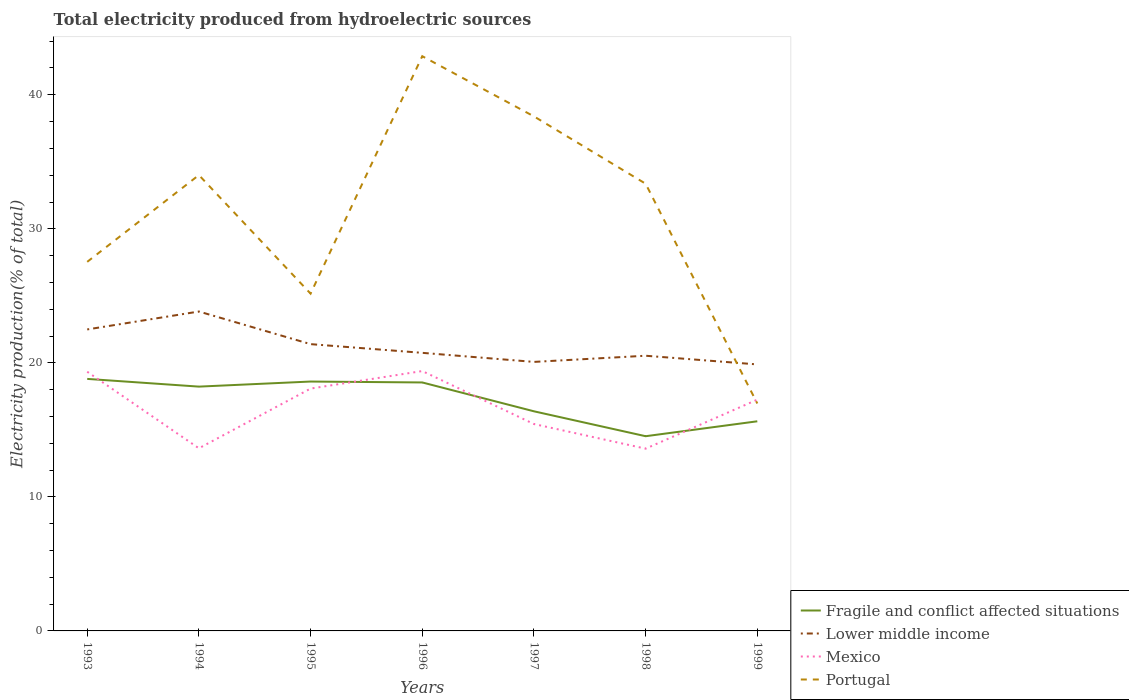Is the number of lines equal to the number of legend labels?
Ensure brevity in your answer.  Yes. Across all years, what is the maximum total electricity produced in Portugal?
Provide a short and direct response. 16.97. What is the total total electricity produced in Fragile and conflict affected situations in the graph?
Ensure brevity in your answer.  2.9. What is the difference between the highest and the second highest total electricity produced in Lower middle income?
Provide a short and direct response. 3.95. How many lines are there?
Provide a succinct answer. 4. How many years are there in the graph?
Provide a succinct answer. 7. Are the values on the major ticks of Y-axis written in scientific E-notation?
Keep it short and to the point. No. Does the graph contain any zero values?
Make the answer very short. No. Does the graph contain grids?
Your answer should be very brief. No. How many legend labels are there?
Your response must be concise. 4. What is the title of the graph?
Give a very brief answer. Total electricity produced from hydroelectric sources. What is the label or title of the X-axis?
Provide a succinct answer. Years. What is the Electricity production(% of total) in Fragile and conflict affected situations in 1993?
Keep it short and to the point. 18.8. What is the Electricity production(% of total) of Lower middle income in 1993?
Your response must be concise. 22.49. What is the Electricity production(% of total) in Mexico in 1993?
Your response must be concise. 19.34. What is the Electricity production(% of total) of Portugal in 1993?
Your answer should be very brief. 27.54. What is the Electricity production(% of total) of Fragile and conflict affected situations in 1994?
Keep it short and to the point. 18.23. What is the Electricity production(% of total) in Lower middle income in 1994?
Keep it short and to the point. 23.83. What is the Electricity production(% of total) in Mexico in 1994?
Provide a short and direct response. 13.63. What is the Electricity production(% of total) of Portugal in 1994?
Provide a short and direct response. 34.01. What is the Electricity production(% of total) in Fragile and conflict affected situations in 1995?
Provide a short and direct response. 18.61. What is the Electricity production(% of total) of Lower middle income in 1995?
Keep it short and to the point. 21.4. What is the Electricity production(% of total) of Mexico in 1995?
Your answer should be very brief. 18.08. What is the Electricity production(% of total) in Portugal in 1995?
Your answer should be very brief. 25.16. What is the Electricity production(% of total) of Fragile and conflict affected situations in 1996?
Make the answer very short. 18.54. What is the Electricity production(% of total) of Lower middle income in 1996?
Make the answer very short. 20.75. What is the Electricity production(% of total) of Mexico in 1996?
Your response must be concise. 19.39. What is the Electricity production(% of total) of Portugal in 1996?
Your answer should be compact. 42.88. What is the Electricity production(% of total) of Fragile and conflict affected situations in 1997?
Ensure brevity in your answer.  16.39. What is the Electricity production(% of total) of Lower middle income in 1997?
Provide a short and direct response. 20.07. What is the Electricity production(% of total) of Mexico in 1997?
Provide a short and direct response. 15.44. What is the Electricity production(% of total) of Portugal in 1997?
Keep it short and to the point. 38.39. What is the Electricity production(% of total) of Fragile and conflict affected situations in 1998?
Offer a terse response. 14.53. What is the Electricity production(% of total) of Lower middle income in 1998?
Provide a short and direct response. 20.53. What is the Electricity production(% of total) of Mexico in 1998?
Your answer should be very brief. 13.6. What is the Electricity production(% of total) of Portugal in 1998?
Provide a succinct answer. 33.36. What is the Electricity production(% of total) in Fragile and conflict affected situations in 1999?
Offer a terse response. 15.64. What is the Electricity production(% of total) in Lower middle income in 1999?
Provide a short and direct response. 19.88. What is the Electricity production(% of total) in Mexico in 1999?
Provide a succinct answer. 17.26. What is the Electricity production(% of total) in Portugal in 1999?
Offer a very short reply. 16.97. Across all years, what is the maximum Electricity production(% of total) in Fragile and conflict affected situations?
Your answer should be very brief. 18.8. Across all years, what is the maximum Electricity production(% of total) in Lower middle income?
Your answer should be compact. 23.83. Across all years, what is the maximum Electricity production(% of total) of Mexico?
Ensure brevity in your answer.  19.39. Across all years, what is the maximum Electricity production(% of total) of Portugal?
Your answer should be compact. 42.88. Across all years, what is the minimum Electricity production(% of total) of Fragile and conflict affected situations?
Your response must be concise. 14.53. Across all years, what is the minimum Electricity production(% of total) of Lower middle income?
Ensure brevity in your answer.  19.88. Across all years, what is the minimum Electricity production(% of total) in Mexico?
Your response must be concise. 13.6. Across all years, what is the minimum Electricity production(% of total) of Portugal?
Your answer should be very brief. 16.97. What is the total Electricity production(% of total) in Fragile and conflict affected situations in the graph?
Provide a succinct answer. 120.72. What is the total Electricity production(% of total) in Lower middle income in the graph?
Your answer should be very brief. 148.95. What is the total Electricity production(% of total) in Mexico in the graph?
Offer a terse response. 116.72. What is the total Electricity production(% of total) in Portugal in the graph?
Keep it short and to the point. 218.31. What is the difference between the Electricity production(% of total) in Fragile and conflict affected situations in 1993 and that in 1994?
Your answer should be very brief. 0.58. What is the difference between the Electricity production(% of total) of Lower middle income in 1993 and that in 1994?
Provide a succinct answer. -1.34. What is the difference between the Electricity production(% of total) in Mexico in 1993 and that in 1994?
Provide a succinct answer. 5.71. What is the difference between the Electricity production(% of total) of Portugal in 1993 and that in 1994?
Your response must be concise. -6.47. What is the difference between the Electricity production(% of total) of Fragile and conflict affected situations in 1993 and that in 1995?
Ensure brevity in your answer.  0.2. What is the difference between the Electricity production(% of total) of Lower middle income in 1993 and that in 1995?
Keep it short and to the point. 1.1. What is the difference between the Electricity production(% of total) of Mexico in 1993 and that in 1995?
Your answer should be very brief. 1.26. What is the difference between the Electricity production(% of total) in Portugal in 1993 and that in 1995?
Provide a succinct answer. 2.37. What is the difference between the Electricity production(% of total) in Fragile and conflict affected situations in 1993 and that in 1996?
Keep it short and to the point. 0.27. What is the difference between the Electricity production(% of total) in Lower middle income in 1993 and that in 1996?
Your response must be concise. 1.75. What is the difference between the Electricity production(% of total) of Mexico in 1993 and that in 1996?
Give a very brief answer. -0.05. What is the difference between the Electricity production(% of total) in Portugal in 1993 and that in 1996?
Make the answer very short. -15.34. What is the difference between the Electricity production(% of total) of Fragile and conflict affected situations in 1993 and that in 1997?
Your answer should be very brief. 2.42. What is the difference between the Electricity production(% of total) in Lower middle income in 1993 and that in 1997?
Make the answer very short. 2.42. What is the difference between the Electricity production(% of total) of Mexico in 1993 and that in 1997?
Keep it short and to the point. 3.9. What is the difference between the Electricity production(% of total) in Portugal in 1993 and that in 1997?
Offer a terse response. -10.85. What is the difference between the Electricity production(% of total) in Fragile and conflict affected situations in 1993 and that in 1998?
Provide a short and direct response. 4.28. What is the difference between the Electricity production(% of total) in Lower middle income in 1993 and that in 1998?
Offer a very short reply. 1.96. What is the difference between the Electricity production(% of total) of Mexico in 1993 and that in 1998?
Give a very brief answer. 5.74. What is the difference between the Electricity production(% of total) of Portugal in 1993 and that in 1998?
Keep it short and to the point. -5.83. What is the difference between the Electricity production(% of total) in Fragile and conflict affected situations in 1993 and that in 1999?
Offer a very short reply. 3.16. What is the difference between the Electricity production(% of total) in Lower middle income in 1993 and that in 1999?
Offer a very short reply. 2.61. What is the difference between the Electricity production(% of total) in Mexico in 1993 and that in 1999?
Make the answer very short. 2.08. What is the difference between the Electricity production(% of total) in Portugal in 1993 and that in 1999?
Keep it short and to the point. 10.57. What is the difference between the Electricity production(% of total) in Fragile and conflict affected situations in 1994 and that in 1995?
Keep it short and to the point. -0.38. What is the difference between the Electricity production(% of total) of Lower middle income in 1994 and that in 1995?
Provide a short and direct response. 2.43. What is the difference between the Electricity production(% of total) in Mexico in 1994 and that in 1995?
Make the answer very short. -4.46. What is the difference between the Electricity production(% of total) in Portugal in 1994 and that in 1995?
Provide a short and direct response. 8.85. What is the difference between the Electricity production(% of total) of Fragile and conflict affected situations in 1994 and that in 1996?
Make the answer very short. -0.31. What is the difference between the Electricity production(% of total) in Lower middle income in 1994 and that in 1996?
Offer a very short reply. 3.08. What is the difference between the Electricity production(% of total) of Mexico in 1994 and that in 1996?
Your response must be concise. -5.76. What is the difference between the Electricity production(% of total) in Portugal in 1994 and that in 1996?
Provide a succinct answer. -8.87. What is the difference between the Electricity production(% of total) of Fragile and conflict affected situations in 1994 and that in 1997?
Your answer should be compact. 1.84. What is the difference between the Electricity production(% of total) of Lower middle income in 1994 and that in 1997?
Your answer should be very brief. 3.76. What is the difference between the Electricity production(% of total) in Mexico in 1994 and that in 1997?
Your answer should be very brief. -1.81. What is the difference between the Electricity production(% of total) of Portugal in 1994 and that in 1997?
Make the answer very short. -4.38. What is the difference between the Electricity production(% of total) of Fragile and conflict affected situations in 1994 and that in 1998?
Your answer should be very brief. 3.7. What is the difference between the Electricity production(% of total) in Lower middle income in 1994 and that in 1998?
Ensure brevity in your answer.  3.3. What is the difference between the Electricity production(% of total) in Mexico in 1994 and that in 1998?
Provide a short and direct response. 0.03. What is the difference between the Electricity production(% of total) in Portugal in 1994 and that in 1998?
Provide a succinct answer. 0.65. What is the difference between the Electricity production(% of total) in Fragile and conflict affected situations in 1994 and that in 1999?
Your response must be concise. 2.59. What is the difference between the Electricity production(% of total) in Lower middle income in 1994 and that in 1999?
Give a very brief answer. 3.95. What is the difference between the Electricity production(% of total) in Mexico in 1994 and that in 1999?
Provide a succinct answer. -3.63. What is the difference between the Electricity production(% of total) of Portugal in 1994 and that in 1999?
Provide a short and direct response. 17.04. What is the difference between the Electricity production(% of total) in Fragile and conflict affected situations in 1995 and that in 1996?
Give a very brief answer. 0.07. What is the difference between the Electricity production(% of total) in Lower middle income in 1995 and that in 1996?
Your answer should be compact. 0.65. What is the difference between the Electricity production(% of total) in Mexico in 1995 and that in 1996?
Your answer should be compact. -1.31. What is the difference between the Electricity production(% of total) of Portugal in 1995 and that in 1996?
Your response must be concise. -17.71. What is the difference between the Electricity production(% of total) in Fragile and conflict affected situations in 1995 and that in 1997?
Give a very brief answer. 2.22. What is the difference between the Electricity production(% of total) in Lower middle income in 1995 and that in 1997?
Provide a short and direct response. 1.33. What is the difference between the Electricity production(% of total) of Mexico in 1995 and that in 1997?
Your answer should be compact. 2.65. What is the difference between the Electricity production(% of total) in Portugal in 1995 and that in 1997?
Your response must be concise. -13.22. What is the difference between the Electricity production(% of total) of Fragile and conflict affected situations in 1995 and that in 1998?
Your answer should be compact. 4.08. What is the difference between the Electricity production(% of total) in Lower middle income in 1995 and that in 1998?
Provide a succinct answer. 0.87. What is the difference between the Electricity production(% of total) in Mexico in 1995 and that in 1998?
Ensure brevity in your answer.  4.48. What is the difference between the Electricity production(% of total) of Portugal in 1995 and that in 1998?
Your answer should be very brief. -8.2. What is the difference between the Electricity production(% of total) of Fragile and conflict affected situations in 1995 and that in 1999?
Your response must be concise. 2.97. What is the difference between the Electricity production(% of total) of Lower middle income in 1995 and that in 1999?
Your answer should be very brief. 1.51. What is the difference between the Electricity production(% of total) of Mexico in 1995 and that in 1999?
Your answer should be compact. 0.83. What is the difference between the Electricity production(% of total) in Portugal in 1995 and that in 1999?
Keep it short and to the point. 8.2. What is the difference between the Electricity production(% of total) in Fragile and conflict affected situations in 1996 and that in 1997?
Give a very brief answer. 2.15. What is the difference between the Electricity production(% of total) in Lower middle income in 1996 and that in 1997?
Your answer should be compact. 0.68. What is the difference between the Electricity production(% of total) of Mexico in 1996 and that in 1997?
Keep it short and to the point. 3.95. What is the difference between the Electricity production(% of total) in Portugal in 1996 and that in 1997?
Provide a short and direct response. 4.49. What is the difference between the Electricity production(% of total) in Fragile and conflict affected situations in 1996 and that in 1998?
Offer a very short reply. 4.01. What is the difference between the Electricity production(% of total) of Lower middle income in 1996 and that in 1998?
Provide a succinct answer. 0.22. What is the difference between the Electricity production(% of total) of Mexico in 1996 and that in 1998?
Provide a short and direct response. 5.79. What is the difference between the Electricity production(% of total) of Portugal in 1996 and that in 1998?
Offer a terse response. 9.51. What is the difference between the Electricity production(% of total) in Fragile and conflict affected situations in 1996 and that in 1999?
Offer a very short reply. 2.9. What is the difference between the Electricity production(% of total) in Lower middle income in 1996 and that in 1999?
Make the answer very short. 0.86. What is the difference between the Electricity production(% of total) of Mexico in 1996 and that in 1999?
Your answer should be very brief. 2.13. What is the difference between the Electricity production(% of total) in Portugal in 1996 and that in 1999?
Provide a succinct answer. 25.91. What is the difference between the Electricity production(% of total) of Fragile and conflict affected situations in 1997 and that in 1998?
Provide a succinct answer. 1.86. What is the difference between the Electricity production(% of total) in Lower middle income in 1997 and that in 1998?
Keep it short and to the point. -0.46. What is the difference between the Electricity production(% of total) of Mexico in 1997 and that in 1998?
Ensure brevity in your answer.  1.84. What is the difference between the Electricity production(% of total) of Portugal in 1997 and that in 1998?
Make the answer very short. 5.02. What is the difference between the Electricity production(% of total) of Fragile and conflict affected situations in 1997 and that in 1999?
Your answer should be very brief. 0.75. What is the difference between the Electricity production(% of total) of Lower middle income in 1997 and that in 1999?
Keep it short and to the point. 0.19. What is the difference between the Electricity production(% of total) in Mexico in 1997 and that in 1999?
Your answer should be compact. -1.82. What is the difference between the Electricity production(% of total) of Portugal in 1997 and that in 1999?
Provide a succinct answer. 21.42. What is the difference between the Electricity production(% of total) in Fragile and conflict affected situations in 1998 and that in 1999?
Your response must be concise. -1.11. What is the difference between the Electricity production(% of total) in Lower middle income in 1998 and that in 1999?
Offer a terse response. 0.65. What is the difference between the Electricity production(% of total) of Mexico in 1998 and that in 1999?
Give a very brief answer. -3.66. What is the difference between the Electricity production(% of total) of Portugal in 1998 and that in 1999?
Keep it short and to the point. 16.4. What is the difference between the Electricity production(% of total) of Fragile and conflict affected situations in 1993 and the Electricity production(% of total) of Lower middle income in 1994?
Give a very brief answer. -5.03. What is the difference between the Electricity production(% of total) in Fragile and conflict affected situations in 1993 and the Electricity production(% of total) in Mexico in 1994?
Provide a succinct answer. 5.18. What is the difference between the Electricity production(% of total) in Fragile and conflict affected situations in 1993 and the Electricity production(% of total) in Portugal in 1994?
Offer a terse response. -15.21. What is the difference between the Electricity production(% of total) of Lower middle income in 1993 and the Electricity production(% of total) of Mexico in 1994?
Offer a very short reply. 8.87. What is the difference between the Electricity production(% of total) in Lower middle income in 1993 and the Electricity production(% of total) in Portugal in 1994?
Give a very brief answer. -11.52. What is the difference between the Electricity production(% of total) in Mexico in 1993 and the Electricity production(% of total) in Portugal in 1994?
Offer a very short reply. -14.67. What is the difference between the Electricity production(% of total) of Fragile and conflict affected situations in 1993 and the Electricity production(% of total) of Lower middle income in 1995?
Make the answer very short. -2.59. What is the difference between the Electricity production(% of total) of Fragile and conflict affected situations in 1993 and the Electricity production(% of total) of Mexico in 1995?
Your answer should be compact. 0.72. What is the difference between the Electricity production(% of total) of Fragile and conflict affected situations in 1993 and the Electricity production(% of total) of Portugal in 1995?
Offer a terse response. -6.36. What is the difference between the Electricity production(% of total) in Lower middle income in 1993 and the Electricity production(% of total) in Mexico in 1995?
Your answer should be very brief. 4.41. What is the difference between the Electricity production(% of total) of Lower middle income in 1993 and the Electricity production(% of total) of Portugal in 1995?
Keep it short and to the point. -2.67. What is the difference between the Electricity production(% of total) of Mexico in 1993 and the Electricity production(% of total) of Portugal in 1995?
Keep it short and to the point. -5.83. What is the difference between the Electricity production(% of total) of Fragile and conflict affected situations in 1993 and the Electricity production(% of total) of Lower middle income in 1996?
Give a very brief answer. -1.94. What is the difference between the Electricity production(% of total) of Fragile and conflict affected situations in 1993 and the Electricity production(% of total) of Mexico in 1996?
Provide a short and direct response. -0.59. What is the difference between the Electricity production(% of total) of Fragile and conflict affected situations in 1993 and the Electricity production(% of total) of Portugal in 1996?
Your answer should be very brief. -24.08. What is the difference between the Electricity production(% of total) of Lower middle income in 1993 and the Electricity production(% of total) of Mexico in 1996?
Provide a short and direct response. 3.1. What is the difference between the Electricity production(% of total) of Lower middle income in 1993 and the Electricity production(% of total) of Portugal in 1996?
Keep it short and to the point. -20.39. What is the difference between the Electricity production(% of total) in Mexico in 1993 and the Electricity production(% of total) in Portugal in 1996?
Provide a succinct answer. -23.54. What is the difference between the Electricity production(% of total) of Fragile and conflict affected situations in 1993 and the Electricity production(% of total) of Lower middle income in 1997?
Your response must be concise. -1.27. What is the difference between the Electricity production(% of total) in Fragile and conflict affected situations in 1993 and the Electricity production(% of total) in Mexico in 1997?
Offer a very short reply. 3.37. What is the difference between the Electricity production(% of total) of Fragile and conflict affected situations in 1993 and the Electricity production(% of total) of Portugal in 1997?
Offer a very short reply. -19.59. What is the difference between the Electricity production(% of total) in Lower middle income in 1993 and the Electricity production(% of total) in Mexico in 1997?
Keep it short and to the point. 7.06. What is the difference between the Electricity production(% of total) in Lower middle income in 1993 and the Electricity production(% of total) in Portugal in 1997?
Provide a short and direct response. -15.9. What is the difference between the Electricity production(% of total) of Mexico in 1993 and the Electricity production(% of total) of Portugal in 1997?
Provide a short and direct response. -19.05. What is the difference between the Electricity production(% of total) of Fragile and conflict affected situations in 1993 and the Electricity production(% of total) of Lower middle income in 1998?
Your answer should be very brief. -1.73. What is the difference between the Electricity production(% of total) of Fragile and conflict affected situations in 1993 and the Electricity production(% of total) of Mexico in 1998?
Ensure brevity in your answer.  5.2. What is the difference between the Electricity production(% of total) of Fragile and conflict affected situations in 1993 and the Electricity production(% of total) of Portugal in 1998?
Keep it short and to the point. -14.56. What is the difference between the Electricity production(% of total) in Lower middle income in 1993 and the Electricity production(% of total) in Mexico in 1998?
Offer a terse response. 8.89. What is the difference between the Electricity production(% of total) in Lower middle income in 1993 and the Electricity production(% of total) in Portugal in 1998?
Your response must be concise. -10.87. What is the difference between the Electricity production(% of total) of Mexico in 1993 and the Electricity production(% of total) of Portugal in 1998?
Keep it short and to the point. -14.03. What is the difference between the Electricity production(% of total) of Fragile and conflict affected situations in 1993 and the Electricity production(% of total) of Lower middle income in 1999?
Keep it short and to the point. -1.08. What is the difference between the Electricity production(% of total) of Fragile and conflict affected situations in 1993 and the Electricity production(% of total) of Mexico in 1999?
Make the answer very short. 1.55. What is the difference between the Electricity production(% of total) in Fragile and conflict affected situations in 1993 and the Electricity production(% of total) in Portugal in 1999?
Your response must be concise. 1.84. What is the difference between the Electricity production(% of total) in Lower middle income in 1993 and the Electricity production(% of total) in Mexico in 1999?
Your answer should be very brief. 5.24. What is the difference between the Electricity production(% of total) of Lower middle income in 1993 and the Electricity production(% of total) of Portugal in 1999?
Give a very brief answer. 5.53. What is the difference between the Electricity production(% of total) of Mexico in 1993 and the Electricity production(% of total) of Portugal in 1999?
Make the answer very short. 2.37. What is the difference between the Electricity production(% of total) in Fragile and conflict affected situations in 1994 and the Electricity production(% of total) in Lower middle income in 1995?
Offer a very short reply. -3.17. What is the difference between the Electricity production(% of total) of Fragile and conflict affected situations in 1994 and the Electricity production(% of total) of Mexico in 1995?
Offer a very short reply. 0.15. What is the difference between the Electricity production(% of total) of Fragile and conflict affected situations in 1994 and the Electricity production(% of total) of Portugal in 1995?
Ensure brevity in your answer.  -6.94. What is the difference between the Electricity production(% of total) in Lower middle income in 1994 and the Electricity production(% of total) in Mexico in 1995?
Keep it short and to the point. 5.75. What is the difference between the Electricity production(% of total) of Lower middle income in 1994 and the Electricity production(% of total) of Portugal in 1995?
Provide a short and direct response. -1.33. What is the difference between the Electricity production(% of total) in Mexico in 1994 and the Electricity production(% of total) in Portugal in 1995?
Your response must be concise. -11.54. What is the difference between the Electricity production(% of total) of Fragile and conflict affected situations in 1994 and the Electricity production(% of total) of Lower middle income in 1996?
Your answer should be compact. -2.52. What is the difference between the Electricity production(% of total) in Fragile and conflict affected situations in 1994 and the Electricity production(% of total) in Mexico in 1996?
Ensure brevity in your answer.  -1.16. What is the difference between the Electricity production(% of total) in Fragile and conflict affected situations in 1994 and the Electricity production(% of total) in Portugal in 1996?
Ensure brevity in your answer.  -24.65. What is the difference between the Electricity production(% of total) in Lower middle income in 1994 and the Electricity production(% of total) in Mexico in 1996?
Give a very brief answer. 4.44. What is the difference between the Electricity production(% of total) in Lower middle income in 1994 and the Electricity production(% of total) in Portugal in 1996?
Your response must be concise. -19.05. What is the difference between the Electricity production(% of total) of Mexico in 1994 and the Electricity production(% of total) of Portugal in 1996?
Provide a short and direct response. -29.25. What is the difference between the Electricity production(% of total) of Fragile and conflict affected situations in 1994 and the Electricity production(% of total) of Lower middle income in 1997?
Make the answer very short. -1.84. What is the difference between the Electricity production(% of total) in Fragile and conflict affected situations in 1994 and the Electricity production(% of total) in Mexico in 1997?
Ensure brevity in your answer.  2.79. What is the difference between the Electricity production(% of total) in Fragile and conflict affected situations in 1994 and the Electricity production(% of total) in Portugal in 1997?
Your answer should be compact. -20.16. What is the difference between the Electricity production(% of total) in Lower middle income in 1994 and the Electricity production(% of total) in Mexico in 1997?
Provide a succinct answer. 8.39. What is the difference between the Electricity production(% of total) in Lower middle income in 1994 and the Electricity production(% of total) in Portugal in 1997?
Offer a very short reply. -14.56. What is the difference between the Electricity production(% of total) of Mexico in 1994 and the Electricity production(% of total) of Portugal in 1997?
Your answer should be compact. -24.76. What is the difference between the Electricity production(% of total) in Fragile and conflict affected situations in 1994 and the Electricity production(% of total) in Lower middle income in 1998?
Ensure brevity in your answer.  -2.3. What is the difference between the Electricity production(% of total) in Fragile and conflict affected situations in 1994 and the Electricity production(% of total) in Mexico in 1998?
Your answer should be very brief. 4.63. What is the difference between the Electricity production(% of total) of Fragile and conflict affected situations in 1994 and the Electricity production(% of total) of Portugal in 1998?
Give a very brief answer. -15.14. What is the difference between the Electricity production(% of total) in Lower middle income in 1994 and the Electricity production(% of total) in Mexico in 1998?
Provide a succinct answer. 10.23. What is the difference between the Electricity production(% of total) in Lower middle income in 1994 and the Electricity production(% of total) in Portugal in 1998?
Offer a very short reply. -9.53. What is the difference between the Electricity production(% of total) of Mexico in 1994 and the Electricity production(% of total) of Portugal in 1998?
Your answer should be very brief. -19.74. What is the difference between the Electricity production(% of total) of Fragile and conflict affected situations in 1994 and the Electricity production(% of total) of Lower middle income in 1999?
Keep it short and to the point. -1.66. What is the difference between the Electricity production(% of total) in Fragile and conflict affected situations in 1994 and the Electricity production(% of total) in Mexico in 1999?
Make the answer very short. 0.97. What is the difference between the Electricity production(% of total) of Fragile and conflict affected situations in 1994 and the Electricity production(% of total) of Portugal in 1999?
Your answer should be compact. 1.26. What is the difference between the Electricity production(% of total) of Lower middle income in 1994 and the Electricity production(% of total) of Mexico in 1999?
Your response must be concise. 6.57. What is the difference between the Electricity production(% of total) in Lower middle income in 1994 and the Electricity production(% of total) in Portugal in 1999?
Your answer should be compact. 6.86. What is the difference between the Electricity production(% of total) of Mexico in 1994 and the Electricity production(% of total) of Portugal in 1999?
Your answer should be compact. -3.34. What is the difference between the Electricity production(% of total) of Fragile and conflict affected situations in 1995 and the Electricity production(% of total) of Lower middle income in 1996?
Provide a short and direct response. -2.14. What is the difference between the Electricity production(% of total) of Fragile and conflict affected situations in 1995 and the Electricity production(% of total) of Mexico in 1996?
Your answer should be compact. -0.78. What is the difference between the Electricity production(% of total) in Fragile and conflict affected situations in 1995 and the Electricity production(% of total) in Portugal in 1996?
Provide a succinct answer. -24.27. What is the difference between the Electricity production(% of total) of Lower middle income in 1995 and the Electricity production(% of total) of Mexico in 1996?
Offer a terse response. 2.01. What is the difference between the Electricity production(% of total) of Lower middle income in 1995 and the Electricity production(% of total) of Portugal in 1996?
Make the answer very short. -21.48. What is the difference between the Electricity production(% of total) of Mexico in 1995 and the Electricity production(% of total) of Portugal in 1996?
Provide a short and direct response. -24.8. What is the difference between the Electricity production(% of total) of Fragile and conflict affected situations in 1995 and the Electricity production(% of total) of Lower middle income in 1997?
Provide a succinct answer. -1.47. What is the difference between the Electricity production(% of total) of Fragile and conflict affected situations in 1995 and the Electricity production(% of total) of Mexico in 1997?
Ensure brevity in your answer.  3.17. What is the difference between the Electricity production(% of total) of Fragile and conflict affected situations in 1995 and the Electricity production(% of total) of Portugal in 1997?
Offer a very short reply. -19.78. What is the difference between the Electricity production(% of total) in Lower middle income in 1995 and the Electricity production(% of total) in Mexico in 1997?
Give a very brief answer. 5.96. What is the difference between the Electricity production(% of total) in Lower middle income in 1995 and the Electricity production(% of total) in Portugal in 1997?
Your response must be concise. -16.99. What is the difference between the Electricity production(% of total) in Mexico in 1995 and the Electricity production(% of total) in Portugal in 1997?
Offer a terse response. -20.31. What is the difference between the Electricity production(% of total) of Fragile and conflict affected situations in 1995 and the Electricity production(% of total) of Lower middle income in 1998?
Make the answer very short. -1.93. What is the difference between the Electricity production(% of total) of Fragile and conflict affected situations in 1995 and the Electricity production(% of total) of Mexico in 1998?
Offer a terse response. 5.01. What is the difference between the Electricity production(% of total) of Fragile and conflict affected situations in 1995 and the Electricity production(% of total) of Portugal in 1998?
Give a very brief answer. -14.76. What is the difference between the Electricity production(% of total) in Lower middle income in 1995 and the Electricity production(% of total) in Mexico in 1998?
Your answer should be compact. 7.8. What is the difference between the Electricity production(% of total) in Lower middle income in 1995 and the Electricity production(% of total) in Portugal in 1998?
Your answer should be compact. -11.97. What is the difference between the Electricity production(% of total) of Mexico in 1995 and the Electricity production(% of total) of Portugal in 1998?
Offer a terse response. -15.28. What is the difference between the Electricity production(% of total) in Fragile and conflict affected situations in 1995 and the Electricity production(% of total) in Lower middle income in 1999?
Your response must be concise. -1.28. What is the difference between the Electricity production(% of total) of Fragile and conflict affected situations in 1995 and the Electricity production(% of total) of Mexico in 1999?
Give a very brief answer. 1.35. What is the difference between the Electricity production(% of total) of Fragile and conflict affected situations in 1995 and the Electricity production(% of total) of Portugal in 1999?
Ensure brevity in your answer.  1.64. What is the difference between the Electricity production(% of total) in Lower middle income in 1995 and the Electricity production(% of total) in Mexico in 1999?
Ensure brevity in your answer.  4.14. What is the difference between the Electricity production(% of total) of Lower middle income in 1995 and the Electricity production(% of total) of Portugal in 1999?
Provide a succinct answer. 4.43. What is the difference between the Electricity production(% of total) in Mexico in 1995 and the Electricity production(% of total) in Portugal in 1999?
Your answer should be very brief. 1.11. What is the difference between the Electricity production(% of total) in Fragile and conflict affected situations in 1996 and the Electricity production(% of total) in Lower middle income in 1997?
Make the answer very short. -1.53. What is the difference between the Electricity production(% of total) in Fragile and conflict affected situations in 1996 and the Electricity production(% of total) in Mexico in 1997?
Provide a succinct answer. 3.1. What is the difference between the Electricity production(% of total) of Fragile and conflict affected situations in 1996 and the Electricity production(% of total) of Portugal in 1997?
Your response must be concise. -19.85. What is the difference between the Electricity production(% of total) in Lower middle income in 1996 and the Electricity production(% of total) in Mexico in 1997?
Keep it short and to the point. 5.31. What is the difference between the Electricity production(% of total) of Lower middle income in 1996 and the Electricity production(% of total) of Portugal in 1997?
Provide a succinct answer. -17.64. What is the difference between the Electricity production(% of total) in Mexico in 1996 and the Electricity production(% of total) in Portugal in 1997?
Keep it short and to the point. -19. What is the difference between the Electricity production(% of total) of Fragile and conflict affected situations in 1996 and the Electricity production(% of total) of Lower middle income in 1998?
Make the answer very short. -1.99. What is the difference between the Electricity production(% of total) of Fragile and conflict affected situations in 1996 and the Electricity production(% of total) of Mexico in 1998?
Your response must be concise. 4.94. What is the difference between the Electricity production(% of total) of Fragile and conflict affected situations in 1996 and the Electricity production(% of total) of Portugal in 1998?
Offer a terse response. -14.83. What is the difference between the Electricity production(% of total) of Lower middle income in 1996 and the Electricity production(% of total) of Mexico in 1998?
Offer a terse response. 7.15. What is the difference between the Electricity production(% of total) of Lower middle income in 1996 and the Electricity production(% of total) of Portugal in 1998?
Provide a short and direct response. -12.62. What is the difference between the Electricity production(% of total) in Mexico in 1996 and the Electricity production(% of total) in Portugal in 1998?
Your answer should be compact. -13.98. What is the difference between the Electricity production(% of total) of Fragile and conflict affected situations in 1996 and the Electricity production(% of total) of Lower middle income in 1999?
Give a very brief answer. -1.35. What is the difference between the Electricity production(% of total) of Fragile and conflict affected situations in 1996 and the Electricity production(% of total) of Mexico in 1999?
Offer a terse response. 1.28. What is the difference between the Electricity production(% of total) of Fragile and conflict affected situations in 1996 and the Electricity production(% of total) of Portugal in 1999?
Ensure brevity in your answer.  1.57. What is the difference between the Electricity production(% of total) in Lower middle income in 1996 and the Electricity production(% of total) in Mexico in 1999?
Make the answer very short. 3.49. What is the difference between the Electricity production(% of total) in Lower middle income in 1996 and the Electricity production(% of total) in Portugal in 1999?
Your answer should be compact. 3.78. What is the difference between the Electricity production(% of total) in Mexico in 1996 and the Electricity production(% of total) in Portugal in 1999?
Provide a succinct answer. 2.42. What is the difference between the Electricity production(% of total) in Fragile and conflict affected situations in 1997 and the Electricity production(% of total) in Lower middle income in 1998?
Offer a very short reply. -4.15. What is the difference between the Electricity production(% of total) of Fragile and conflict affected situations in 1997 and the Electricity production(% of total) of Mexico in 1998?
Your answer should be very brief. 2.79. What is the difference between the Electricity production(% of total) in Fragile and conflict affected situations in 1997 and the Electricity production(% of total) in Portugal in 1998?
Ensure brevity in your answer.  -16.98. What is the difference between the Electricity production(% of total) in Lower middle income in 1997 and the Electricity production(% of total) in Mexico in 1998?
Offer a terse response. 6.47. What is the difference between the Electricity production(% of total) of Lower middle income in 1997 and the Electricity production(% of total) of Portugal in 1998?
Make the answer very short. -13.29. What is the difference between the Electricity production(% of total) in Mexico in 1997 and the Electricity production(% of total) in Portugal in 1998?
Offer a terse response. -17.93. What is the difference between the Electricity production(% of total) of Fragile and conflict affected situations in 1997 and the Electricity production(% of total) of Lower middle income in 1999?
Your response must be concise. -3.5. What is the difference between the Electricity production(% of total) of Fragile and conflict affected situations in 1997 and the Electricity production(% of total) of Mexico in 1999?
Offer a terse response. -0.87. What is the difference between the Electricity production(% of total) in Fragile and conflict affected situations in 1997 and the Electricity production(% of total) in Portugal in 1999?
Offer a very short reply. -0.58. What is the difference between the Electricity production(% of total) of Lower middle income in 1997 and the Electricity production(% of total) of Mexico in 1999?
Offer a very short reply. 2.81. What is the difference between the Electricity production(% of total) of Lower middle income in 1997 and the Electricity production(% of total) of Portugal in 1999?
Make the answer very short. 3.1. What is the difference between the Electricity production(% of total) in Mexico in 1997 and the Electricity production(% of total) in Portugal in 1999?
Give a very brief answer. -1.53. What is the difference between the Electricity production(% of total) in Fragile and conflict affected situations in 1998 and the Electricity production(% of total) in Lower middle income in 1999?
Your answer should be compact. -5.36. What is the difference between the Electricity production(% of total) in Fragile and conflict affected situations in 1998 and the Electricity production(% of total) in Mexico in 1999?
Your response must be concise. -2.73. What is the difference between the Electricity production(% of total) in Fragile and conflict affected situations in 1998 and the Electricity production(% of total) in Portugal in 1999?
Offer a terse response. -2.44. What is the difference between the Electricity production(% of total) in Lower middle income in 1998 and the Electricity production(% of total) in Mexico in 1999?
Make the answer very short. 3.27. What is the difference between the Electricity production(% of total) of Lower middle income in 1998 and the Electricity production(% of total) of Portugal in 1999?
Your answer should be compact. 3.56. What is the difference between the Electricity production(% of total) of Mexico in 1998 and the Electricity production(% of total) of Portugal in 1999?
Your response must be concise. -3.37. What is the average Electricity production(% of total) of Fragile and conflict affected situations per year?
Provide a short and direct response. 17.25. What is the average Electricity production(% of total) of Lower middle income per year?
Your answer should be compact. 21.28. What is the average Electricity production(% of total) in Mexico per year?
Give a very brief answer. 16.67. What is the average Electricity production(% of total) in Portugal per year?
Give a very brief answer. 31.19. In the year 1993, what is the difference between the Electricity production(% of total) of Fragile and conflict affected situations and Electricity production(% of total) of Lower middle income?
Your answer should be compact. -3.69. In the year 1993, what is the difference between the Electricity production(% of total) in Fragile and conflict affected situations and Electricity production(% of total) in Mexico?
Your answer should be compact. -0.53. In the year 1993, what is the difference between the Electricity production(% of total) in Fragile and conflict affected situations and Electricity production(% of total) in Portugal?
Keep it short and to the point. -8.73. In the year 1993, what is the difference between the Electricity production(% of total) of Lower middle income and Electricity production(% of total) of Mexico?
Ensure brevity in your answer.  3.16. In the year 1993, what is the difference between the Electricity production(% of total) of Lower middle income and Electricity production(% of total) of Portugal?
Offer a very short reply. -5.04. In the year 1993, what is the difference between the Electricity production(% of total) of Mexico and Electricity production(% of total) of Portugal?
Your response must be concise. -8.2. In the year 1994, what is the difference between the Electricity production(% of total) of Fragile and conflict affected situations and Electricity production(% of total) of Lower middle income?
Provide a short and direct response. -5.6. In the year 1994, what is the difference between the Electricity production(% of total) of Fragile and conflict affected situations and Electricity production(% of total) of Mexico?
Ensure brevity in your answer.  4.6. In the year 1994, what is the difference between the Electricity production(% of total) of Fragile and conflict affected situations and Electricity production(% of total) of Portugal?
Make the answer very short. -15.78. In the year 1994, what is the difference between the Electricity production(% of total) of Lower middle income and Electricity production(% of total) of Mexico?
Offer a terse response. 10.2. In the year 1994, what is the difference between the Electricity production(% of total) of Lower middle income and Electricity production(% of total) of Portugal?
Offer a terse response. -10.18. In the year 1994, what is the difference between the Electricity production(% of total) of Mexico and Electricity production(% of total) of Portugal?
Your answer should be very brief. -20.38. In the year 1995, what is the difference between the Electricity production(% of total) in Fragile and conflict affected situations and Electricity production(% of total) in Lower middle income?
Your answer should be compact. -2.79. In the year 1995, what is the difference between the Electricity production(% of total) in Fragile and conflict affected situations and Electricity production(% of total) in Mexico?
Ensure brevity in your answer.  0.52. In the year 1995, what is the difference between the Electricity production(% of total) in Fragile and conflict affected situations and Electricity production(% of total) in Portugal?
Your answer should be compact. -6.56. In the year 1995, what is the difference between the Electricity production(% of total) in Lower middle income and Electricity production(% of total) in Mexico?
Give a very brief answer. 3.32. In the year 1995, what is the difference between the Electricity production(% of total) in Lower middle income and Electricity production(% of total) in Portugal?
Make the answer very short. -3.77. In the year 1995, what is the difference between the Electricity production(% of total) in Mexico and Electricity production(% of total) in Portugal?
Your response must be concise. -7.08. In the year 1996, what is the difference between the Electricity production(% of total) in Fragile and conflict affected situations and Electricity production(% of total) in Lower middle income?
Your answer should be very brief. -2.21. In the year 1996, what is the difference between the Electricity production(% of total) of Fragile and conflict affected situations and Electricity production(% of total) of Mexico?
Your answer should be very brief. -0.85. In the year 1996, what is the difference between the Electricity production(% of total) of Fragile and conflict affected situations and Electricity production(% of total) of Portugal?
Provide a short and direct response. -24.34. In the year 1996, what is the difference between the Electricity production(% of total) of Lower middle income and Electricity production(% of total) of Mexico?
Your response must be concise. 1.36. In the year 1996, what is the difference between the Electricity production(% of total) of Lower middle income and Electricity production(% of total) of Portugal?
Your answer should be compact. -22.13. In the year 1996, what is the difference between the Electricity production(% of total) of Mexico and Electricity production(% of total) of Portugal?
Your answer should be very brief. -23.49. In the year 1997, what is the difference between the Electricity production(% of total) of Fragile and conflict affected situations and Electricity production(% of total) of Lower middle income?
Give a very brief answer. -3.69. In the year 1997, what is the difference between the Electricity production(% of total) of Fragile and conflict affected situations and Electricity production(% of total) of Mexico?
Keep it short and to the point. 0.95. In the year 1997, what is the difference between the Electricity production(% of total) of Fragile and conflict affected situations and Electricity production(% of total) of Portugal?
Your response must be concise. -22. In the year 1997, what is the difference between the Electricity production(% of total) of Lower middle income and Electricity production(% of total) of Mexico?
Provide a short and direct response. 4.64. In the year 1997, what is the difference between the Electricity production(% of total) in Lower middle income and Electricity production(% of total) in Portugal?
Make the answer very short. -18.32. In the year 1997, what is the difference between the Electricity production(% of total) in Mexico and Electricity production(% of total) in Portugal?
Offer a terse response. -22.95. In the year 1998, what is the difference between the Electricity production(% of total) in Fragile and conflict affected situations and Electricity production(% of total) in Lower middle income?
Your answer should be very brief. -6. In the year 1998, what is the difference between the Electricity production(% of total) of Fragile and conflict affected situations and Electricity production(% of total) of Mexico?
Provide a succinct answer. 0.93. In the year 1998, what is the difference between the Electricity production(% of total) in Fragile and conflict affected situations and Electricity production(% of total) in Portugal?
Ensure brevity in your answer.  -18.84. In the year 1998, what is the difference between the Electricity production(% of total) in Lower middle income and Electricity production(% of total) in Mexico?
Your answer should be compact. 6.93. In the year 1998, what is the difference between the Electricity production(% of total) in Lower middle income and Electricity production(% of total) in Portugal?
Your answer should be very brief. -12.83. In the year 1998, what is the difference between the Electricity production(% of total) of Mexico and Electricity production(% of total) of Portugal?
Provide a succinct answer. -19.77. In the year 1999, what is the difference between the Electricity production(% of total) in Fragile and conflict affected situations and Electricity production(% of total) in Lower middle income?
Ensure brevity in your answer.  -4.24. In the year 1999, what is the difference between the Electricity production(% of total) in Fragile and conflict affected situations and Electricity production(% of total) in Mexico?
Your answer should be compact. -1.62. In the year 1999, what is the difference between the Electricity production(% of total) in Fragile and conflict affected situations and Electricity production(% of total) in Portugal?
Your answer should be very brief. -1.33. In the year 1999, what is the difference between the Electricity production(% of total) of Lower middle income and Electricity production(% of total) of Mexico?
Your answer should be very brief. 2.63. In the year 1999, what is the difference between the Electricity production(% of total) in Lower middle income and Electricity production(% of total) in Portugal?
Provide a short and direct response. 2.92. In the year 1999, what is the difference between the Electricity production(% of total) in Mexico and Electricity production(% of total) in Portugal?
Give a very brief answer. 0.29. What is the ratio of the Electricity production(% of total) of Fragile and conflict affected situations in 1993 to that in 1994?
Keep it short and to the point. 1.03. What is the ratio of the Electricity production(% of total) in Lower middle income in 1993 to that in 1994?
Give a very brief answer. 0.94. What is the ratio of the Electricity production(% of total) in Mexico in 1993 to that in 1994?
Offer a terse response. 1.42. What is the ratio of the Electricity production(% of total) of Portugal in 1993 to that in 1994?
Offer a very short reply. 0.81. What is the ratio of the Electricity production(% of total) of Fragile and conflict affected situations in 1993 to that in 1995?
Ensure brevity in your answer.  1.01. What is the ratio of the Electricity production(% of total) of Lower middle income in 1993 to that in 1995?
Your answer should be compact. 1.05. What is the ratio of the Electricity production(% of total) in Mexico in 1993 to that in 1995?
Ensure brevity in your answer.  1.07. What is the ratio of the Electricity production(% of total) in Portugal in 1993 to that in 1995?
Your answer should be compact. 1.09. What is the ratio of the Electricity production(% of total) in Fragile and conflict affected situations in 1993 to that in 1996?
Give a very brief answer. 1.01. What is the ratio of the Electricity production(% of total) of Lower middle income in 1993 to that in 1996?
Your answer should be very brief. 1.08. What is the ratio of the Electricity production(% of total) in Mexico in 1993 to that in 1996?
Your answer should be compact. 1. What is the ratio of the Electricity production(% of total) of Portugal in 1993 to that in 1996?
Provide a succinct answer. 0.64. What is the ratio of the Electricity production(% of total) in Fragile and conflict affected situations in 1993 to that in 1997?
Make the answer very short. 1.15. What is the ratio of the Electricity production(% of total) of Lower middle income in 1993 to that in 1997?
Keep it short and to the point. 1.12. What is the ratio of the Electricity production(% of total) in Mexico in 1993 to that in 1997?
Provide a short and direct response. 1.25. What is the ratio of the Electricity production(% of total) of Portugal in 1993 to that in 1997?
Offer a very short reply. 0.72. What is the ratio of the Electricity production(% of total) in Fragile and conflict affected situations in 1993 to that in 1998?
Your answer should be compact. 1.29. What is the ratio of the Electricity production(% of total) in Lower middle income in 1993 to that in 1998?
Your answer should be compact. 1.1. What is the ratio of the Electricity production(% of total) in Mexico in 1993 to that in 1998?
Keep it short and to the point. 1.42. What is the ratio of the Electricity production(% of total) in Portugal in 1993 to that in 1998?
Your response must be concise. 0.83. What is the ratio of the Electricity production(% of total) of Fragile and conflict affected situations in 1993 to that in 1999?
Your response must be concise. 1.2. What is the ratio of the Electricity production(% of total) in Lower middle income in 1993 to that in 1999?
Make the answer very short. 1.13. What is the ratio of the Electricity production(% of total) of Mexico in 1993 to that in 1999?
Make the answer very short. 1.12. What is the ratio of the Electricity production(% of total) in Portugal in 1993 to that in 1999?
Give a very brief answer. 1.62. What is the ratio of the Electricity production(% of total) of Fragile and conflict affected situations in 1994 to that in 1995?
Ensure brevity in your answer.  0.98. What is the ratio of the Electricity production(% of total) of Lower middle income in 1994 to that in 1995?
Keep it short and to the point. 1.11. What is the ratio of the Electricity production(% of total) of Mexico in 1994 to that in 1995?
Ensure brevity in your answer.  0.75. What is the ratio of the Electricity production(% of total) in Portugal in 1994 to that in 1995?
Your answer should be compact. 1.35. What is the ratio of the Electricity production(% of total) in Fragile and conflict affected situations in 1994 to that in 1996?
Your answer should be compact. 0.98. What is the ratio of the Electricity production(% of total) of Lower middle income in 1994 to that in 1996?
Provide a short and direct response. 1.15. What is the ratio of the Electricity production(% of total) in Mexico in 1994 to that in 1996?
Ensure brevity in your answer.  0.7. What is the ratio of the Electricity production(% of total) in Portugal in 1994 to that in 1996?
Offer a terse response. 0.79. What is the ratio of the Electricity production(% of total) in Fragile and conflict affected situations in 1994 to that in 1997?
Offer a very short reply. 1.11. What is the ratio of the Electricity production(% of total) in Lower middle income in 1994 to that in 1997?
Ensure brevity in your answer.  1.19. What is the ratio of the Electricity production(% of total) of Mexico in 1994 to that in 1997?
Your response must be concise. 0.88. What is the ratio of the Electricity production(% of total) of Portugal in 1994 to that in 1997?
Provide a short and direct response. 0.89. What is the ratio of the Electricity production(% of total) in Fragile and conflict affected situations in 1994 to that in 1998?
Offer a terse response. 1.25. What is the ratio of the Electricity production(% of total) of Lower middle income in 1994 to that in 1998?
Offer a terse response. 1.16. What is the ratio of the Electricity production(% of total) in Mexico in 1994 to that in 1998?
Provide a short and direct response. 1. What is the ratio of the Electricity production(% of total) in Portugal in 1994 to that in 1998?
Your response must be concise. 1.02. What is the ratio of the Electricity production(% of total) in Fragile and conflict affected situations in 1994 to that in 1999?
Keep it short and to the point. 1.17. What is the ratio of the Electricity production(% of total) in Lower middle income in 1994 to that in 1999?
Offer a terse response. 1.2. What is the ratio of the Electricity production(% of total) in Mexico in 1994 to that in 1999?
Offer a very short reply. 0.79. What is the ratio of the Electricity production(% of total) in Portugal in 1994 to that in 1999?
Offer a terse response. 2. What is the ratio of the Electricity production(% of total) in Fragile and conflict affected situations in 1995 to that in 1996?
Offer a very short reply. 1. What is the ratio of the Electricity production(% of total) of Lower middle income in 1995 to that in 1996?
Provide a short and direct response. 1.03. What is the ratio of the Electricity production(% of total) of Mexico in 1995 to that in 1996?
Make the answer very short. 0.93. What is the ratio of the Electricity production(% of total) in Portugal in 1995 to that in 1996?
Provide a succinct answer. 0.59. What is the ratio of the Electricity production(% of total) in Fragile and conflict affected situations in 1995 to that in 1997?
Offer a very short reply. 1.14. What is the ratio of the Electricity production(% of total) of Lower middle income in 1995 to that in 1997?
Give a very brief answer. 1.07. What is the ratio of the Electricity production(% of total) in Mexico in 1995 to that in 1997?
Your response must be concise. 1.17. What is the ratio of the Electricity production(% of total) in Portugal in 1995 to that in 1997?
Your answer should be very brief. 0.66. What is the ratio of the Electricity production(% of total) in Fragile and conflict affected situations in 1995 to that in 1998?
Provide a short and direct response. 1.28. What is the ratio of the Electricity production(% of total) of Lower middle income in 1995 to that in 1998?
Your answer should be very brief. 1.04. What is the ratio of the Electricity production(% of total) in Mexico in 1995 to that in 1998?
Keep it short and to the point. 1.33. What is the ratio of the Electricity production(% of total) of Portugal in 1995 to that in 1998?
Offer a very short reply. 0.75. What is the ratio of the Electricity production(% of total) of Fragile and conflict affected situations in 1995 to that in 1999?
Ensure brevity in your answer.  1.19. What is the ratio of the Electricity production(% of total) in Lower middle income in 1995 to that in 1999?
Make the answer very short. 1.08. What is the ratio of the Electricity production(% of total) of Mexico in 1995 to that in 1999?
Your answer should be compact. 1.05. What is the ratio of the Electricity production(% of total) of Portugal in 1995 to that in 1999?
Provide a succinct answer. 1.48. What is the ratio of the Electricity production(% of total) of Fragile and conflict affected situations in 1996 to that in 1997?
Give a very brief answer. 1.13. What is the ratio of the Electricity production(% of total) of Lower middle income in 1996 to that in 1997?
Offer a terse response. 1.03. What is the ratio of the Electricity production(% of total) in Mexico in 1996 to that in 1997?
Your answer should be compact. 1.26. What is the ratio of the Electricity production(% of total) in Portugal in 1996 to that in 1997?
Give a very brief answer. 1.12. What is the ratio of the Electricity production(% of total) in Fragile and conflict affected situations in 1996 to that in 1998?
Provide a short and direct response. 1.28. What is the ratio of the Electricity production(% of total) of Lower middle income in 1996 to that in 1998?
Your answer should be compact. 1.01. What is the ratio of the Electricity production(% of total) of Mexico in 1996 to that in 1998?
Your answer should be very brief. 1.43. What is the ratio of the Electricity production(% of total) of Portugal in 1996 to that in 1998?
Ensure brevity in your answer.  1.29. What is the ratio of the Electricity production(% of total) of Fragile and conflict affected situations in 1996 to that in 1999?
Provide a short and direct response. 1.19. What is the ratio of the Electricity production(% of total) in Lower middle income in 1996 to that in 1999?
Offer a terse response. 1.04. What is the ratio of the Electricity production(% of total) in Mexico in 1996 to that in 1999?
Offer a terse response. 1.12. What is the ratio of the Electricity production(% of total) of Portugal in 1996 to that in 1999?
Your answer should be compact. 2.53. What is the ratio of the Electricity production(% of total) of Fragile and conflict affected situations in 1997 to that in 1998?
Ensure brevity in your answer.  1.13. What is the ratio of the Electricity production(% of total) in Lower middle income in 1997 to that in 1998?
Make the answer very short. 0.98. What is the ratio of the Electricity production(% of total) in Mexico in 1997 to that in 1998?
Your answer should be compact. 1.14. What is the ratio of the Electricity production(% of total) of Portugal in 1997 to that in 1998?
Your answer should be compact. 1.15. What is the ratio of the Electricity production(% of total) in Fragile and conflict affected situations in 1997 to that in 1999?
Make the answer very short. 1.05. What is the ratio of the Electricity production(% of total) in Lower middle income in 1997 to that in 1999?
Make the answer very short. 1.01. What is the ratio of the Electricity production(% of total) of Mexico in 1997 to that in 1999?
Ensure brevity in your answer.  0.89. What is the ratio of the Electricity production(% of total) in Portugal in 1997 to that in 1999?
Provide a short and direct response. 2.26. What is the ratio of the Electricity production(% of total) of Fragile and conflict affected situations in 1998 to that in 1999?
Your answer should be very brief. 0.93. What is the ratio of the Electricity production(% of total) of Lower middle income in 1998 to that in 1999?
Give a very brief answer. 1.03. What is the ratio of the Electricity production(% of total) of Mexico in 1998 to that in 1999?
Provide a short and direct response. 0.79. What is the ratio of the Electricity production(% of total) of Portugal in 1998 to that in 1999?
Make the answer very short. 1.97. What is the difference between the highest and the second highest Electricity production(% of total) of Fragile and conflict affected situations?
Your response must be concise. 0.2. What is the difference between the highest and the second highest Electricity production(% of total) in Lower middle income?
Your response must be concise. 1.34. What is the difference between the highest and the second highest Electricity production(% of total) of Mexico?
Offer a very short reply. 0.05. What is the difference between the highest and the second highest Electricity production(% of total) of Portugal?
Offer a terse response. 4.49. What is the difference between the highest and the lowest Electricity production(% of total) in Fragile and conflict affected situations?
Your answer should be compact. 4.28. What is the difference between the highest and the lowest Electricity production(% of total) in Lower middle income?
Your answer should be very brief. 3.95. What is the difference between the highest and the lowest Electricity production(% of total) in Mexico?
Your answer should be very brief. 5.79. What is the difference between the highest and the lowest Electricity production(% of total) of Portugal?
Provide a short and direct response. 25.91. 